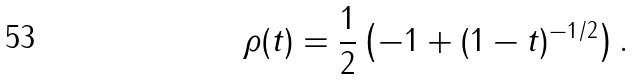<formula> <loc_0><loc_0><loc_500><loc_500>\rho ( t ) = \frac { 1 } { 2 } \left ( - 1 + ( 1 - t ) ^ { - 1 / 2 } \right ) .</formula> 